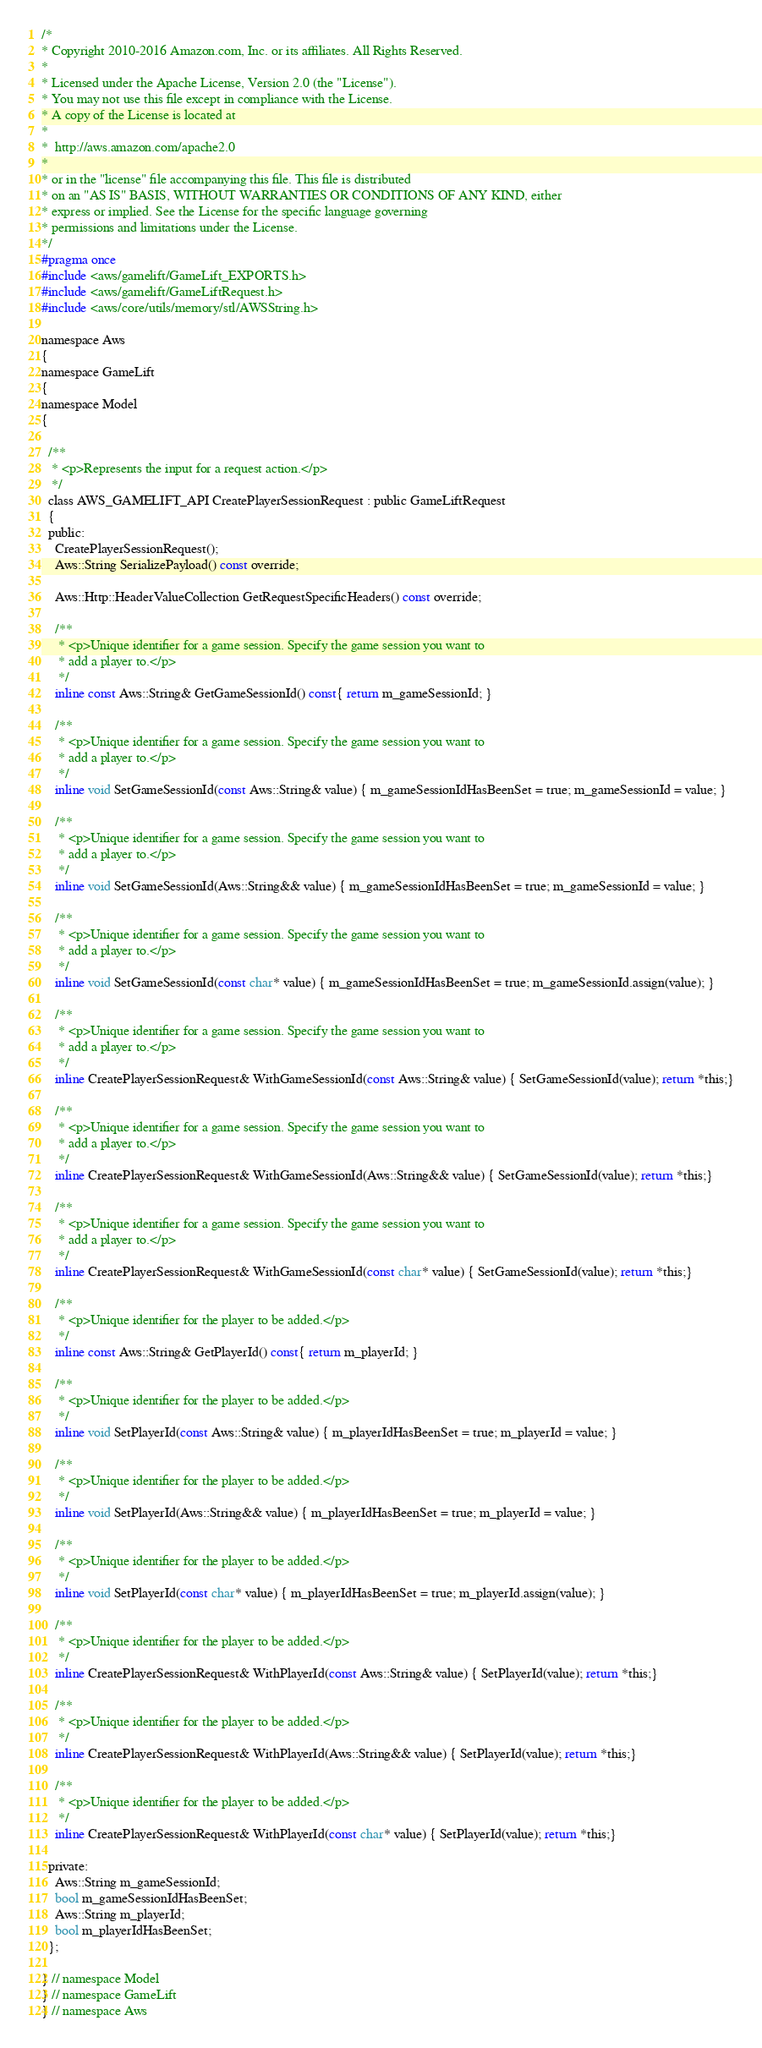<code> <loc_0><loc_0><loc_500><loc_500><_C_>/*
* Copyright 2010-2016 Amazon.com, Inc. or its affiliates. All Rights Reserved.
*
* Licensed under the Apache License, Version 2.0 (the "License").
* You may not use this file except in compliance with the License.
* A copy of the License is located at
*
*  http://aws.amazon.com/apache2.0
*
* or in the "license" file accompanying this file. This file is distributed
* on an "AS IS" BASIS, WITHOUT WARRANTIES OR CONDITIONS OF ANY KIND, either
* express or implied. See the License for the specific language governing
* permissions and limitations under the License.
*/
#pragma once
#include <aws/gamelift/GameLift_EXPORTS.h>
#include <aws/gamelift/GameLiftRequest.h>
#include <aws/core/utils/memory/stl/AWSString.h>

namespace Aws
{
namespace GameLift
{
namespace Model
{

  /**
   * <p>Represents the input for a request action.</p>
   */
  class AWS_GAMELIFT_API CreatePlayerSessionRequest : public GameLiftRequest
  {
  public:
    CreatePlayerSessionRequest();
    Aws::String SerializePayload() const override;

    Aws::Http::HeaderValueCollection GetRequestSpecificHeaders() const override;

    /**
     * <p>Unique identifier for a game session. Specify the game session you want to
     * add a player to.</p>
     */
    inline const Aws::String& GetGameSessionId() const{ return m_gameSessionId; }

    /**
     * <p>Unique identifier for a game session. Specify the game session you want to
     * add a player to.</p>
     */
    inline void SetGameSessionId(const Aws::String& value) { m_gameSessionIdHasBeenSet = true; m_gameSessionId = value; }

    /**
     * <p>Unique identifier for a game session. Specify the game session you want to
     * add a player to.</p>
     */
    inline void SetGameSessionId(Aws::String&& value) { m_gameSessionIdHasBeenSet = true; m_gameSessionId = value; }

    /**
     * <p>Unique identifier for a game session. Specify the game session you want to
     * add a player to.</p>
     */
    inline void SetGameSessionId(const char* value) { m_gameSessionIdHasBeenSet = true; m_gameSessionId.assign(value); }

    /**
     * <p>Unique identifier for a game session. Specify the game session you want to
     * add a player to.</p>
     */
    inline CreatePlayerSessionRequest& WithGameSessionId(const Aws::String& value) { SetGameSessionId(value); return *this;}

    /**
     * <p>Unique identifier for a game session. Specify the game session you want to
     * add a player to.</p>
     */
    inline CreatePlayerSessionRequest& WithGameSessionId(Aws::String&& value) { SetGameSessionId(value); return *this;}

    /**
     * <p>Unique identifier for a game session. Specify the game session you want to
     * add a player to.</p>
     */
    inline CreatePlayerSessionRequest& WithGameSessionId(const char* value) { SetGameSessionId(value); return *this;}

    /**
     * <p>Unique identifier for the player to be added.</p>
     */
    inline const Aws::String& GetPlayerId() const{ return m_playerId; }

    /**
     * <p>Unique identifier for the player to be added.</p>
     */
    inline void SetPlayerId(const Aws::String& value) { m_playerIdHasBeenSet = true; m_playerId = value; }

    /**
     * <p>Unique identifier for the player to be added.</p>
     */
    inline void SetPlayerId(Aws::String&& value) { m_playerIdHasBeenSet = true; m_playerId = value; }

    /**
     * <p>Unique identifier for the player to be added.</p>
     */
    inline void SetPlayerId(const char* value) { m_playerIdHasBeenSet = true; m_playerId.assign(value); }

    /**
     * <p>Unique identifier for the player to be added.</p>
     */
    inline CreatePlayerSessionRequest& WithPlayerId(const Aws::String& value) { SetPlayerId(value); return *this;}

    /**
     * <p>Unique identifier for the player to be added.</p>
     */
    inline CreatePlayerSessionRequest& WithPlayerId(Aws::String&& value) { SetPlayerId(value); return *this;}

    /**
     * <p>Unique identifier for the player to be added.</p>
     */
    inline CreatePlayerSessionRequest& WithPlayerId(const char* value) { SetPlayerId(value); return *this;}

  private:
    Aws::String m_gameSessionId;
    bool m_gameSessionIdHasBeenSet;
    Aws::String m_playerId;
    bool m_playerIdHasBeenSet;
  };

} // namespace Model
} // namespace GameLift
} // namespace Aws
</code> 